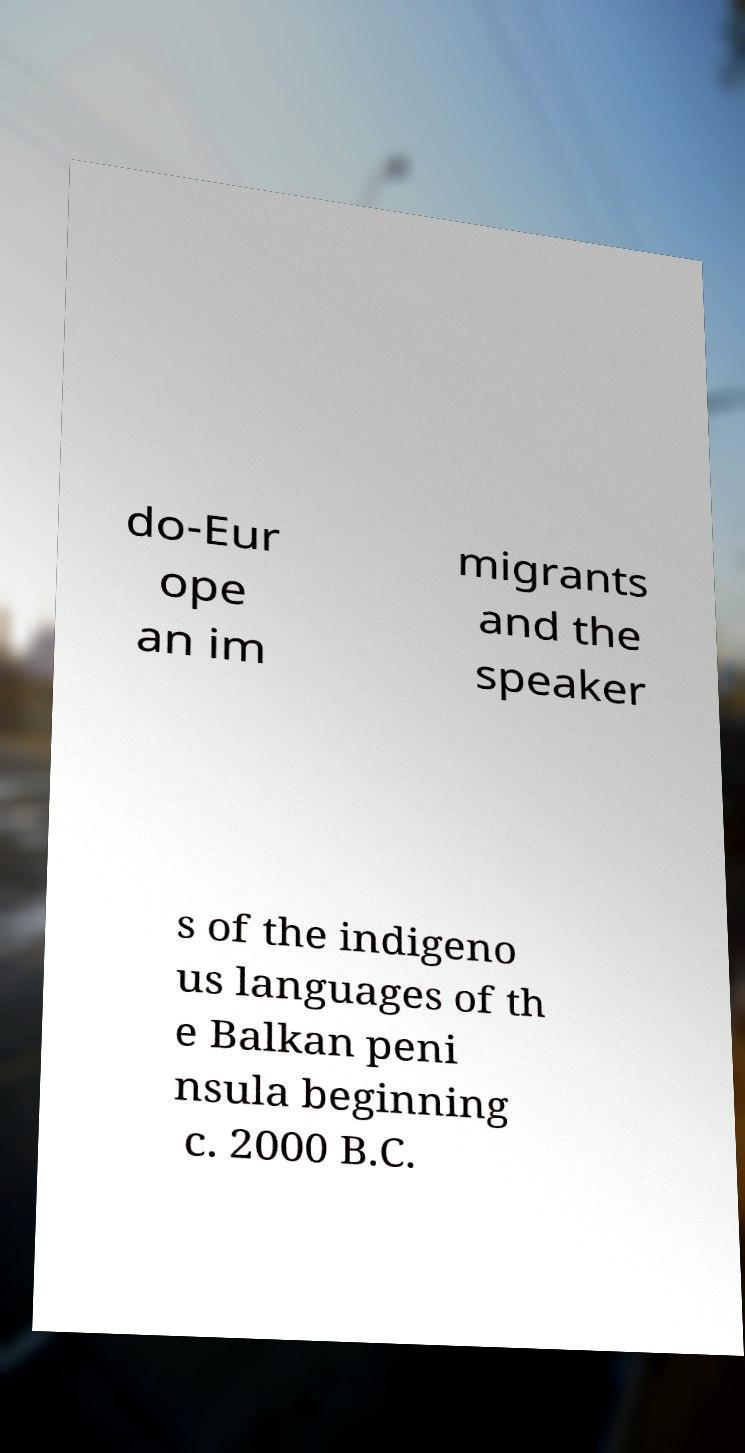There's text embedded in this image that I need extracted. Can you transcribe it verbatim? do-Eur ope an im migrants and the speaker s of the indigeno us languages of th e Balkan peni nsula beginning c. 2000 B.C. 